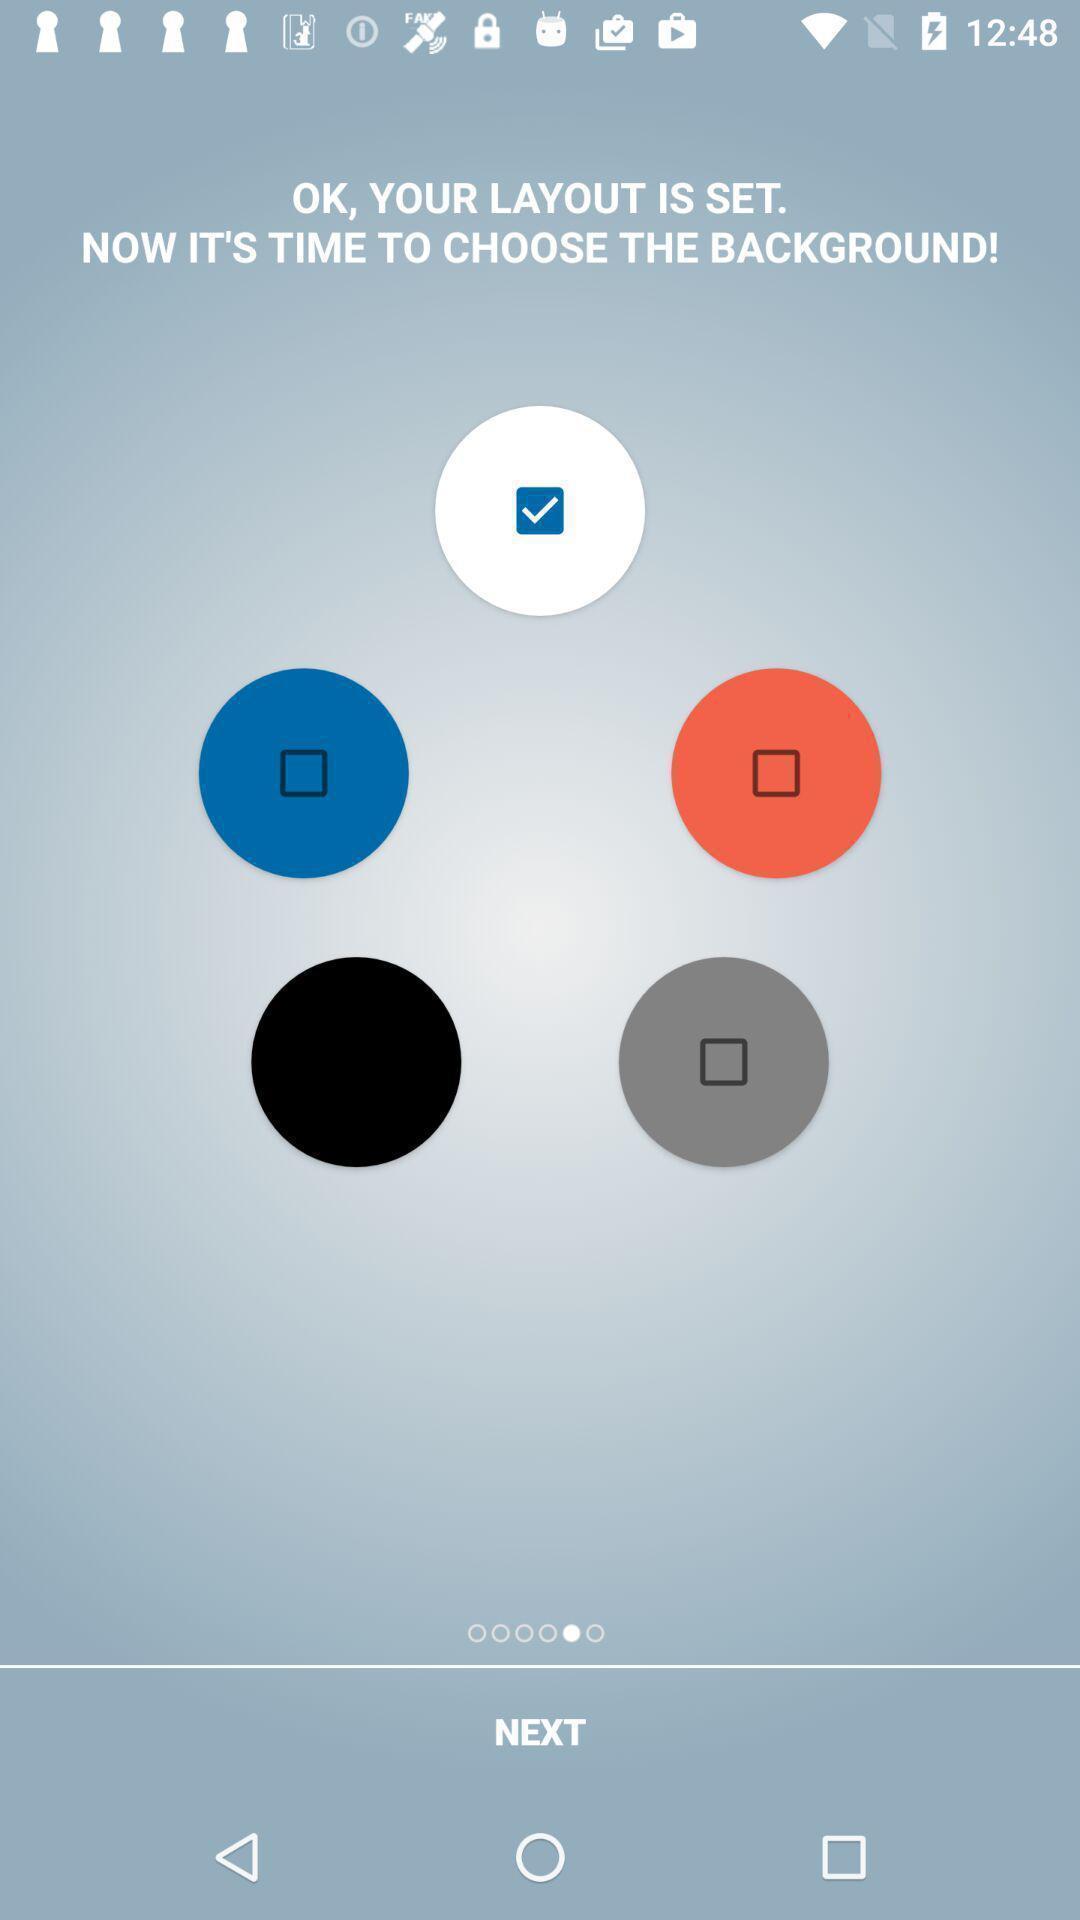Give me a narrative description of this picture. Page displaying to choose the background. 